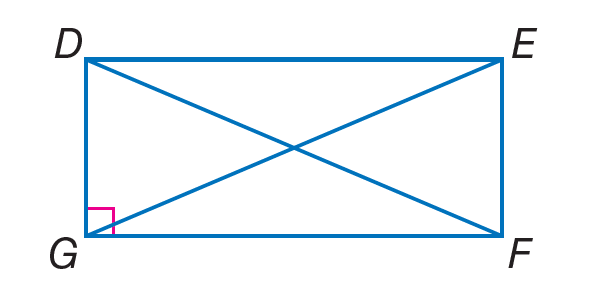Answer the mathemtical geometry problem and directly provide the correct option letter.
Question: Quadrilateral D E F G is a rectangle. If D E = 14 + 2 x and G F = 4(x - 3) + 6, find G F.
Choices: A: 15 B: 28 C: 34 D: 40 C 